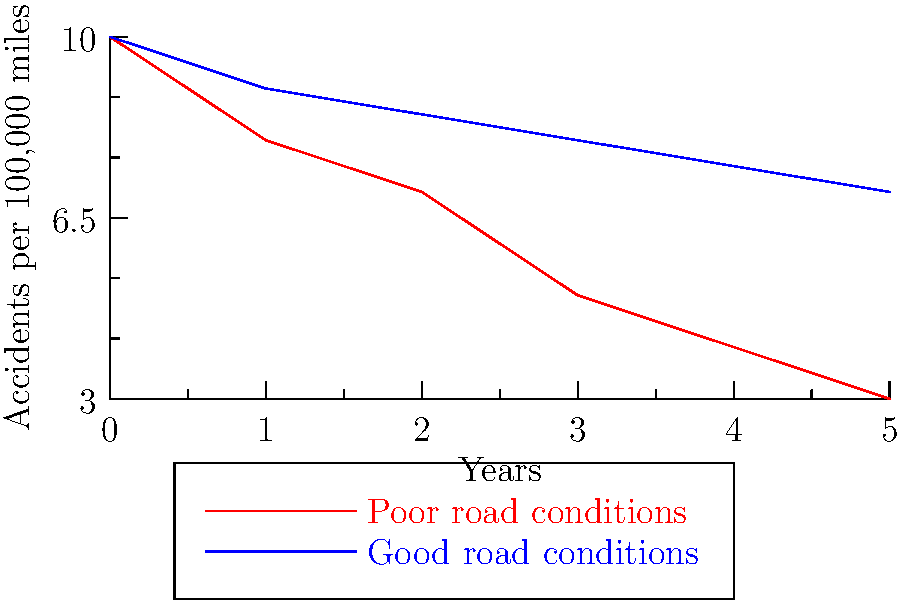The line graph shows the number of trucking accidents per 100,000 miles over a 5-year period under two different road conditions. Based on this data, what would be the most effective argument to support increased funding for road maintenance in your proposed legislation? To answer this question, we need to analyze the graph and its implications:

1. Observe the trends:
   - The red line (poor road conditions) shows a higher number of accidents throughout the period.
   - The blue line (good road conditions) shows a lower number of accidents.

2. Compare the starting points:
   - Both conditions start at 10 accidents per 100,000 miles in year 0.

3. Analyze the rate of decrease:
   - Poor road conditions: Accidents decrease from 10 to 3 over 5 years.
   - Good road conditions: Accidents decrease from 10 to 7 over 5 years.

4. Calculate the total reduction:
   - Poor road conditions: 10 - 3 = 7 accidents reduced
   - Good road conditions: 10 - 7 = 3 accidents reduced

5. Consider the implications:
   - Good road conditions lead to consistently fewer accidents.
   - The gap between the two lines widens over time, indicating a cumulative positive effect of good road conditions.

6. Formulate the argument:
   The most effective argument would be that investing in road maintenance leads to a significant and sustained reduction in trucking accidents over time. This not only improves safety but also potentially reduces long-term costs associated with accidents, such as healthcare, insurance, and lost productivity.
Answer: Investing in road maintenance significantly reduces trucking accidents over time, improving safety and potentially lowering long-term accident-related costs. 